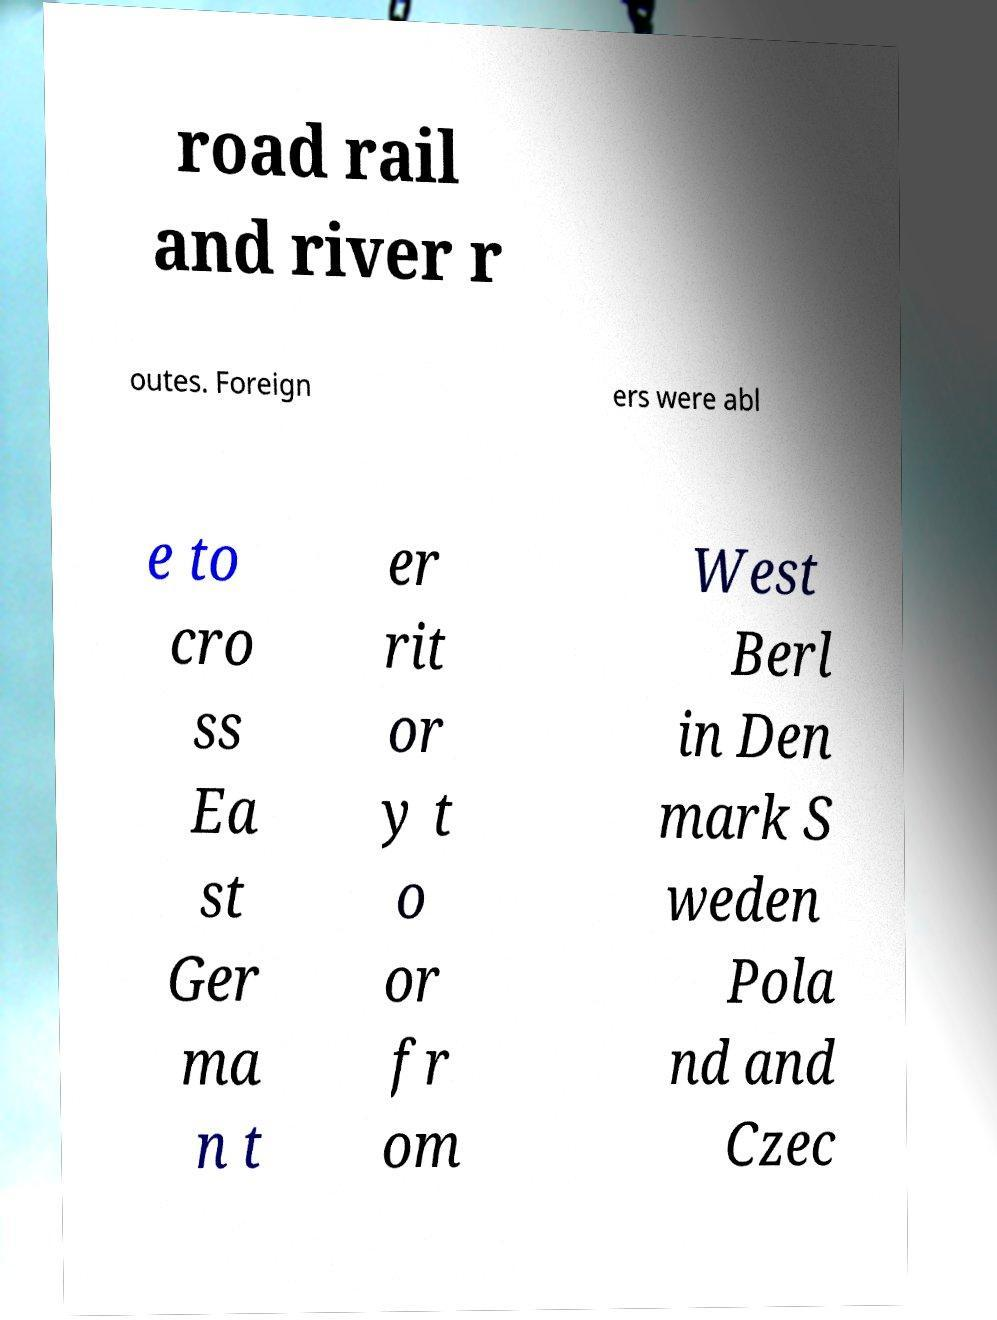Please identify and transcribe the text found in this image. road rail and river r outes. Foreign ers were abl e to cro ss Ea st Ger ma n t er rit or y t o or fr om West Berl in Den mark S weden Pola nd and Czec 